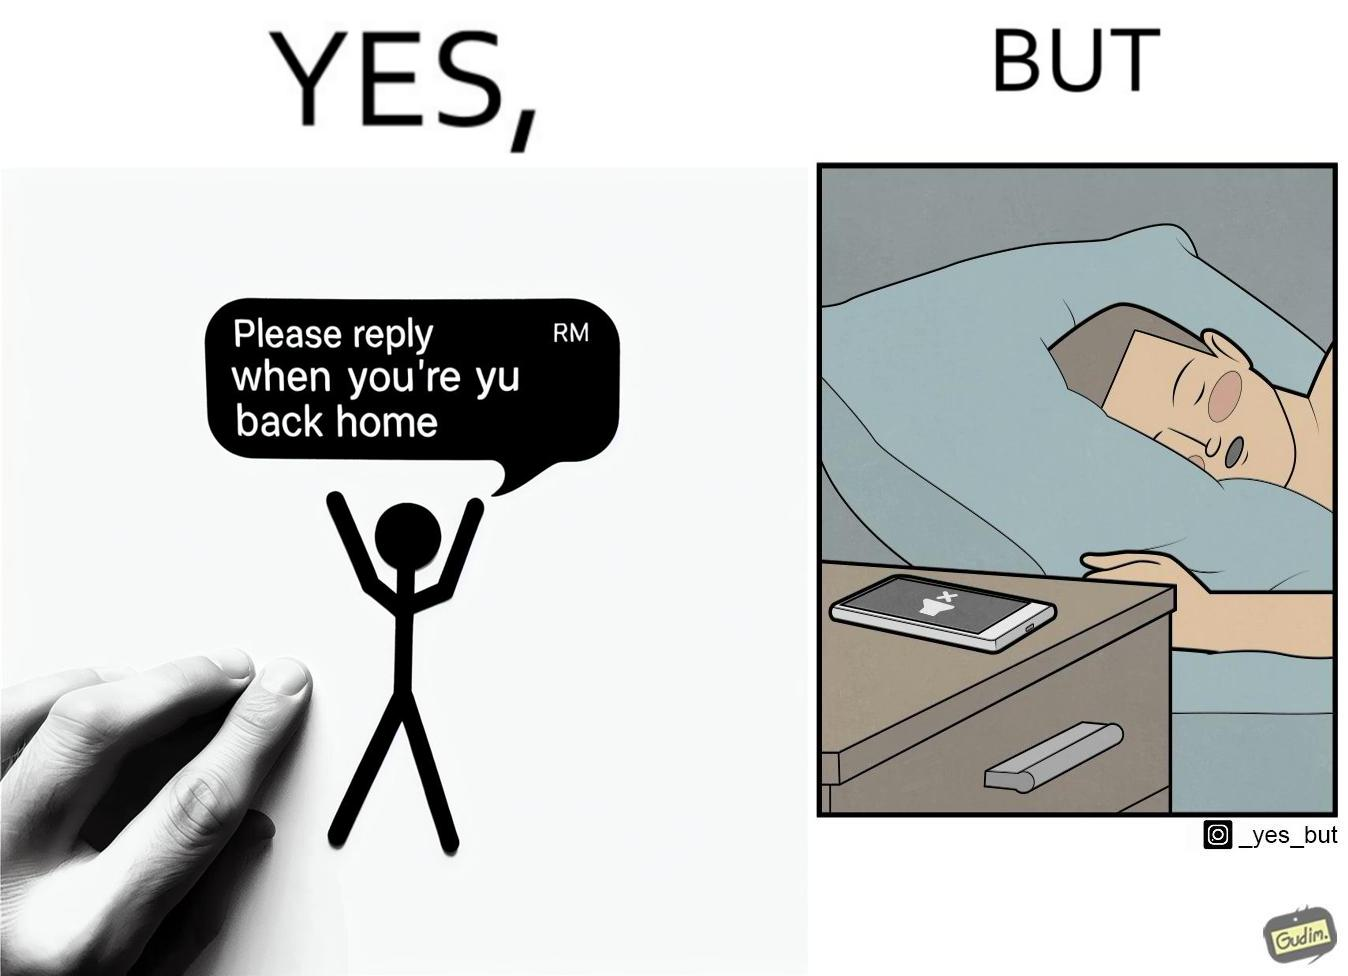What is the satirical meaning behind this image? The images are funny since they show how a sender wants the recipient to revert once he gets back home but the tired recipient ends up falling asleep completely forgetting about the message while the sender keeps waiting for a reply. The fact that the recipient leaves his phone on silent mode makes it even funnier since the probability of the sender being able to contact him becomes even slimmer. 